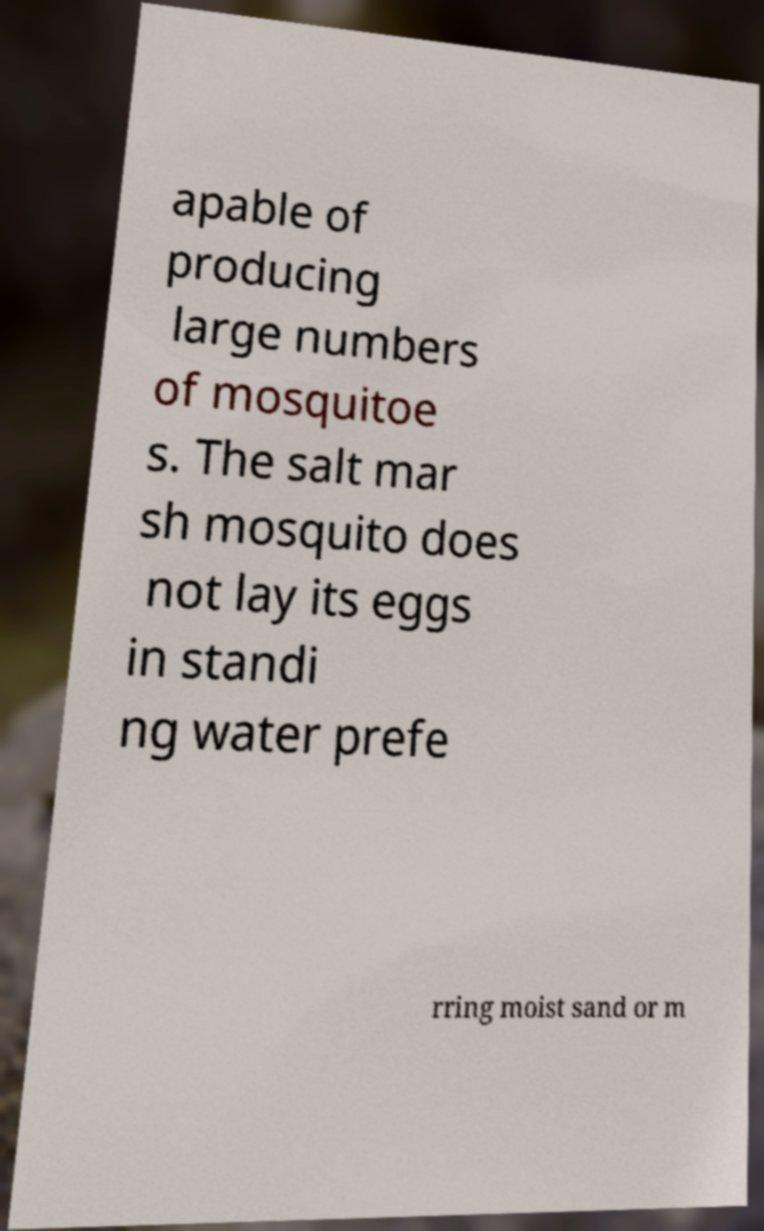What messages or text are displayed in this image? I need them in a readable, typed format. apable of producing large numbers of mosquitoe s. The salt mar sh mosquito does not lay its eggs in standi ng water prefe rring moist sand or m 